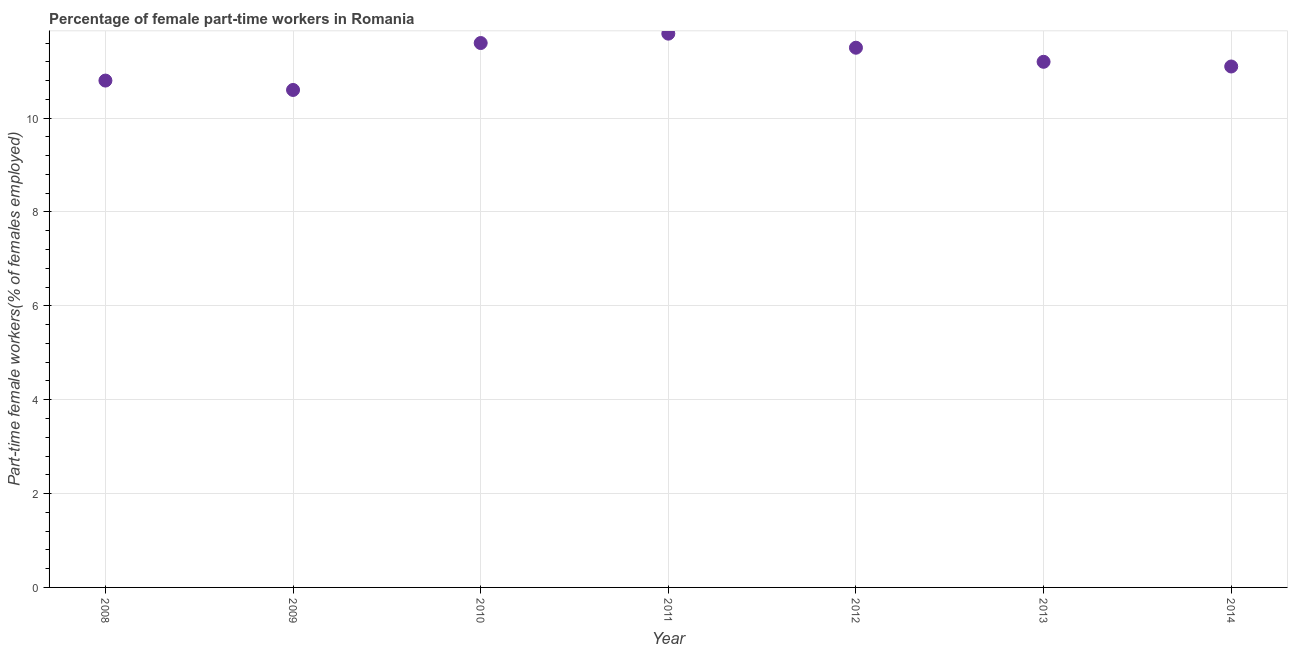What is the percentage of part-time female workers in 2008?
Your answer should be compact. 10.8. Across all years, what is the maximum percentage of part-time female workers?
Ensure brevity in your answer.  11.8. Across all years, what is the minimum percentage of part-time female workers?
Keep it short and to the point. 10.6. In which year was the percentage of part-time female workers minimum?
Your answer should be compact. 2009. What is the sum of the percentage of part-time female workers?
Your answer should be compact. 78.6. What is the average percentage of part-time female workers per year?
Provide a short and direct response. 11.23. What is the median percentage of part-time female workers?
Keep it short and to the point. 11.2. Do a majority of the years between 2010 and 2008 (inclusive) have percentage of part-time female workers greater than 5.6 %?
Keep it short and to the point. No. What is the ratio of the percentage of part-time female workers in 2009 to that in 2010?
Your answer should be very brief. 0.91. Is the difference between the percentage of part-time female workers in 2011 and 2012 greater than the difference between any two years?
Give a very brief answer. No. What is the difference between the highest and the second highest percentage of part-time female workers?
Provide a succinct answer. 0.2. Is the sum of the percentage of part-time female workers in 2012 and 2014 greater than the maximum percentage of part-time female workers across all years?
Your response must be concise. Yes. What is the difference between the highest and the lowest percentage of part-time female workers?
Provide a succinct answer. 1.2. How many dotlines are there?
Your answer should be very brief. 1. How many years are there in the graph?
Provide a succinct answer. 7. What is the difference between two consecutive major ticks on the Y-axis?
Offer a very short reply. 2. Does the graph contain any zero values?
Offer a very short reply. No. What is the title of the graph?
Keep it short and to the point. Percentage of female part-time workers in Romania. What is the label or title of the X-axis?
Offer a terse response. Year. What is the label or title of the Y-axis?
Your answer should be compact. Part-time female workers(% of females employed). What is the Part-time female workers(% of females employed) in 2008?
Ensure brevity in your answer.  10.8. What is the Part-time female workers(% of females employed) in 2009?
Provide a succinct answer. 10.6. What is the Part-time female workers(% of females employed) in 2010?
Provide a succinct answer. 11.6. What is the Part-time female workers(% of females employed) in 2011?
Provide a succinct answer. 11.8. What is the Part-time female workers(% of females employed) in 2012?
Your answer should be compact. 11.5. What is the Part-time female workers(% of females employed) in 2013?
Ensure brevity in your answer.  11.2. What is the Part-time female workers(% of females employed) in 2014?
Offer a very short reply. 11.1. What is the difference between the Part-time female workers(% of females employed) in 2008 and 2010?
Offer a very short reply. -0.8. What is the difference between the Part-time female workers(% of females employed) in 2008 and 2012?
Your answer should be compact. -0.7. What is the difference between the Part-time female workers(% of females employed) in 2008 and 2014?
Your answer should be compact. -0.3. What is the difference between the Part-time female workers(% of females employed) in 2009 and 2011?
Your answer should be very brief. -1.2. What is the difference between the Part-time female workers(% of females employed) in 2009 and 2014?
Give a very brief answer. -0.5. What is the difference between the Part-time female workers(% of females employed) in 2010 and 2013?
Your answer should be very brief. 0.4. What is the difference between the Part-time female workers(% of females employed) in 2010 and 2014?
Your response must be concise. 0.5. What is the difference between the Part-time female workers(% of females employed) in 2011 and 2012?
Your answer should be compact. 0.3. What is the difference between the Part-time female workers(% of females employed) in 2012 and 2013?
Your answer should be compact. 0.3. What is the difference between the Part-time female workers(% of females employed) in 2012 and 2014?
Your answer should be very brief. 0.4. What is the difference between the Part-time female workers(% of females employed) in 2013 and 2014?
Offer a very short reply. 0.1. What is the ratio of the Part-time female workers(% of females employed) in 2008 to that in 2011?
Your response must be concise. 0.92. What is the ratio of the Part-time female workers(% of females employed) in 2008 to that in 2012?
Offer a terse response. 0.94. What is the ratio of the Part-time female workers(% of females employed) in 2008 to that in 2013?
Your answer should be compact. 0.96. What is the ratio of the Part-time female workers(% of females employed) in 2009 to that in 2010?
Keep it short and to the point. 0.91. What is the ratio of the Part-time female workers(% of females employed) in 2009 to that in 2011?
Offer a very short reply. 0.9. What is the ratio of the Part-time female workers(% of females employed) in 2009 to that in 2012?
Your answer should be compact. 0.92. What is the ratio of the Part-time female workers(% of females employed) in 2009 to that in 2013?
Give a very brief answer. 0.95. What is the ratio of the Part-time female workers(% of females employed) in 2009 to that in 2014?
Offer a terse response. 0.95. What is the ratio of the Part-time female workers(% of females employed) in 2010 to that in 2013?
Offer a terse response. 1.04. What is the ratio of the Part-time female workers(% of females employed) in 2010 to that in 2014?
Offer a very short reply. 1.04. What is the ratio of the Part-time female workers(% of females employed) in 2011 to that in 2013?
Give a very brief answer. 1.05. What is the ratio of the Part-time female workers(% of females employed) in 2011 to that in 2014?
Provide a short and direct response. 1.06. What is the ratio of the Part-time female workers(% of females employed) in 2012 to that in 2013?
Make the answer very short. 1.03. What is the ratio of the Part-time female workers(% of females employed) in 2012 to that in 2014?
Your response must be concise. 1.04. 